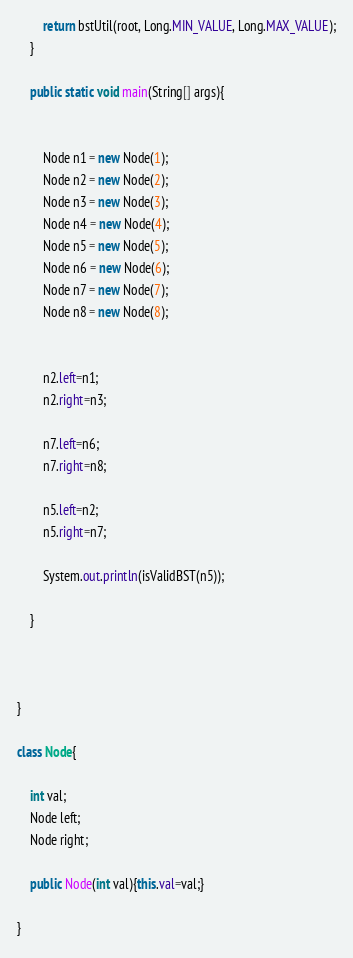Convert code to text. <code><loc_0><loc_0><loc_500><loc_500><_Java_>		return bstUtil(root, Long.MIN_VALUE, Long.MAX_VALUE);
	}

	public static void main(String[] args){
		
		
		Node n1 = new Node(1);
		Node n2 = new Node(2);
		Node n3 = new Node(3);
		Node n4 = new Node(4);
		Node n5 = new Node(5);
		Node n6 = new Node(6);
		Node n7 = new Node(7);
		Node n8 = new Node(8);


		n2.left=n1;
		n2.right=n3;

		n7.left=n6;
		n7.right=n8;

		n5.left=n2;
		n5.right=n7;

		System.out.println(isValidBST(n5));

	}



}

class Node{
	
	int val;
	Node left;
	Node right;

	public Node(int val){this.val=val;}

}</code> 